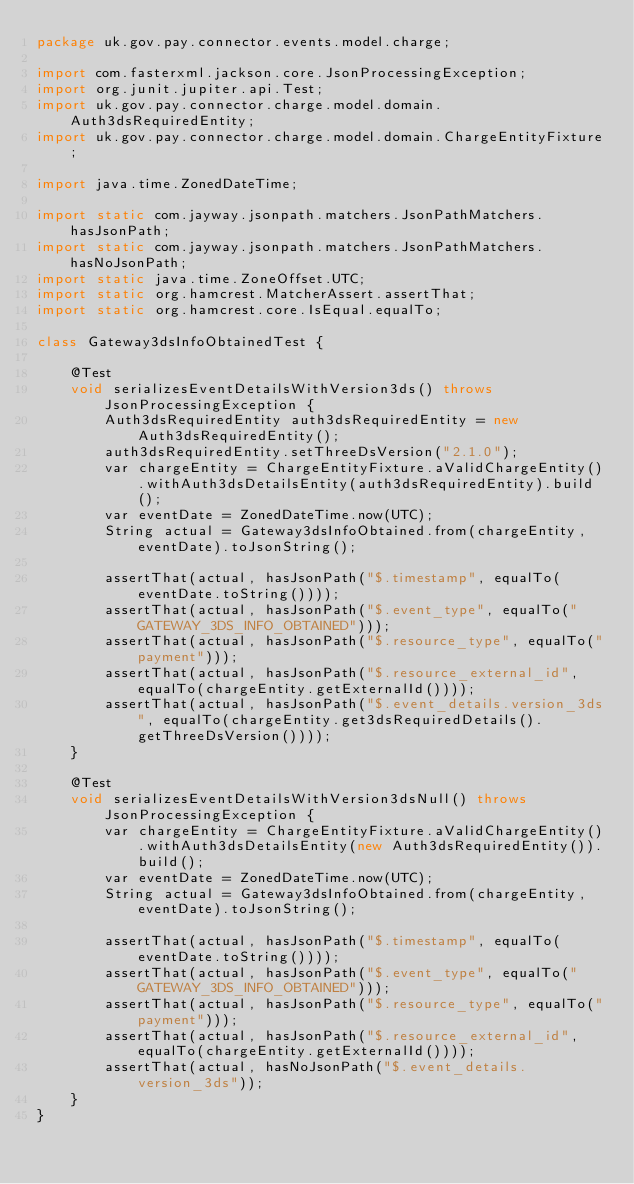<code> <loc_0><loc_0><loc_500><loc_500><_Java_>package uk.gov.pay.connector.events.model.charge;

import com.fasterxml.jackson.core.JsonProcessingException;
import org.junit.jupiter.api.Test;
import uk.gov.pay.connector.charge.model.domain.Auth3dsRequiredEntity;
import uk.gov.pay.connector.charge.model.domain.ChargeEntityFixture;

import java.time.ZonedDateTime;

import static com.jayway.jsonpath.matchers.JsonPathMatchers.hasJsonPath;
import static com.jayway.jsonpath.matchers.JsonPathMatchers.hasNoJsonPath;
import static java.time.ZoneOffset.UTC;
import static org.hamcrest.MatcherAssert.assertThat;
import static org.hamcrest.core.IsEqual.equalTo;

class Gateway3dsInfoObtainedTest {

    @Test
    void serializesEventDetailsWithVersion3ds() throws JsonProcessingException {
        Auth3dsRequiredEntity auth3dsRequiredEntity = new Auth3dsRequiredEntity();
        auth3dsRequiredEntity.setThreeDsVersion("2.1.0");
        var chargeEntity = ChargeEntityFixture.aValidChargeEntity().withAuth3dsDetailsEntity(auth3dsRequiredEntity).build();
        var eventDate = ZonedDateTime.now(UTC);
        String actual = Gateway3dsInfoObtained.from(chargeEntity, eventDate).toJsonString();

        assertThat(actual, hasJsonPath("$.timestamp", equalTo(eventDate.toString())));
        assertThat(actual, hasJsonPath("$.event_type", equalTo("GATEWAY_3DS_INFO_OBTAINED")));
        assertThat(actual, hasJsonPath("$.resource_type", equalTo("payment")));
        assertThat(actual, hasJsonPath("$.resource_external_id", equalTo(chargeEntity.getExternalId())));
        assertThat(actual, hasJsonPath("$.event_details.version_3ds", equalTo(chargeEntity.get3dsRequiredDetails().getThreeDsVersion())));
    }

    @Test
    void serializesEventDetailsWithVersion3dsNull() throws JsonProcessingException {
        var chargeEntity = ChargeEntityFixture.aValidChargeEntity().withAuth3dsDetailsEntity(new Auth3dsRequiredEntity()).build();
        var eventDate = ZonedDateTime.now(UTC);
        String actual = Gateway3dsInfoObtained.from(chargeEntity, eventDate).toJsonString();

        assertThat(actual, hasJsonPath("$.timestamp", equalTo(eventDate.toString())));
        assertThat(actual, hasJsonPath("$.event_type", equalTo("GATEWAY_3DS_INFO_OBTAINED")));
        assertThat(actual, hasJsonPath("$.resource_type", equalTo("payment")));
        assertThat(actual, hasJsonPath("$.resource_external_id", equalTo(chargeEntity.getExternalId())));
        assertThat(actual, hasNoJsonPath("$.event_details.version_3ds"));
    }
}</code> 